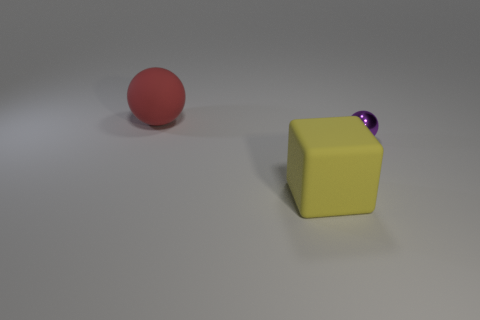Add 3 purple cylinders. How many objects exist? 6 Subtract all blocks. How many objects are left? 2 Add 2 rubber balls. How many rubber balls are left? 3 Add 2 large yellow rubber things. How many large yellow rubber things exist? 3 Subtract 0 brown cylinders. How many objects are left? 3 Subtract all tiny blue cylinders. Subtract all cubes. How many objects are left? 2 